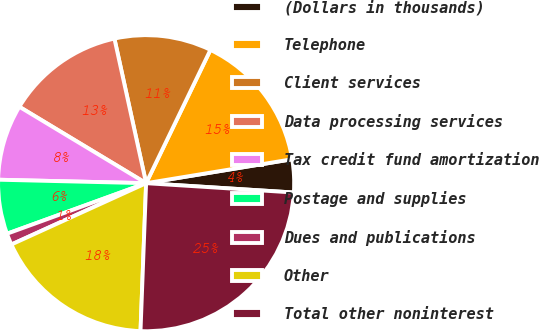Convert chart to OTSL. <chart><loc_0><loc_0><loc_500><loc_500><pie_chart><fcel>(Dollars in thousands)<fcel>Telephone<fcel>Client services<fcel>Data processing services<fcel>Tax credit fund amortization<fcel>Postage and supplies<fcel>Dues and publications<fcel>Other<fcel>Total other noninterest<nl><fcel>3.59%<fcel>15.26%<fcel>10.59%<fcel>12.93%<fcel>8.26%<fcel>5.92%<fcel>1.25%<fcel>17.6%<fcel>24.6%<nl></chart> 